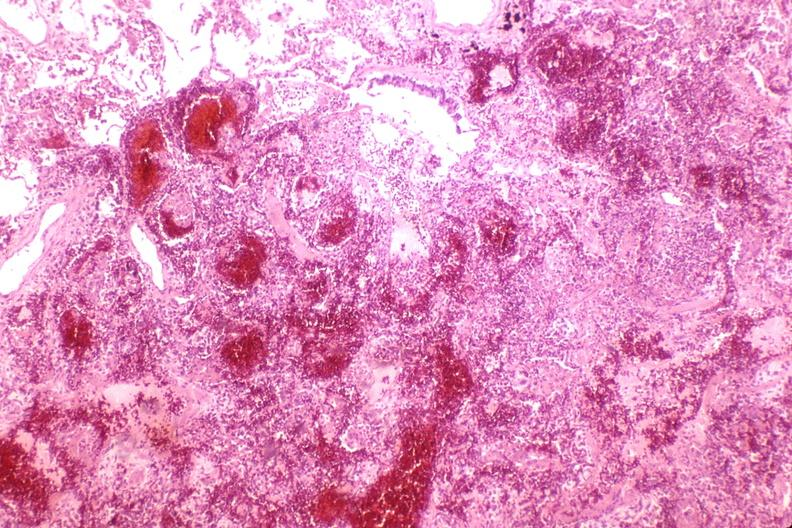does anencephaly show lung, hemorrhagic bronchopneumonia, wilson 's disease?
Answer the question using a single word or phrase. No 